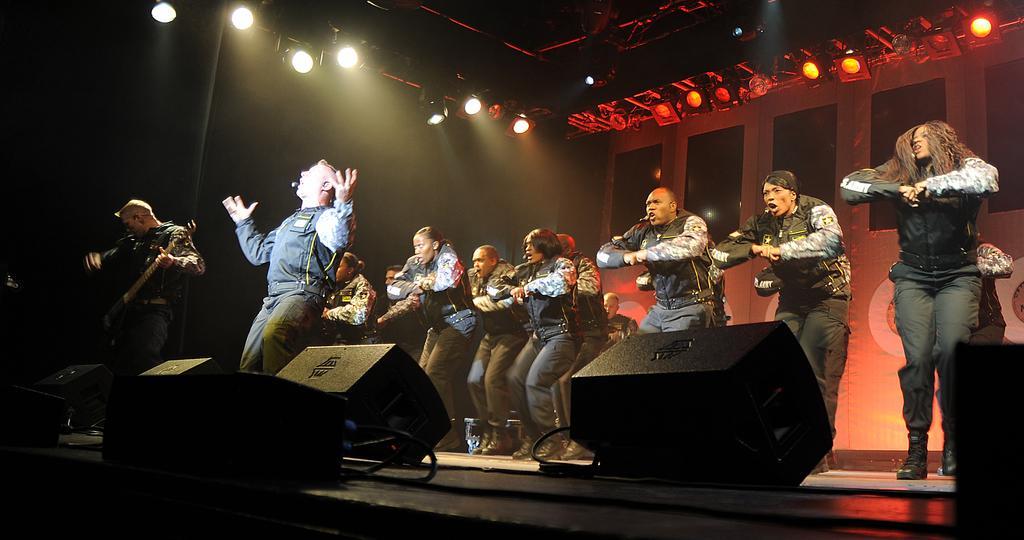Could you give a brief overview of what you see in this image? In the stage many dancers are dancing. In front of them a man is singing beside him a man is playing guitar. On the top there are lights. In the background there are lights. In the foreground there are lights. 